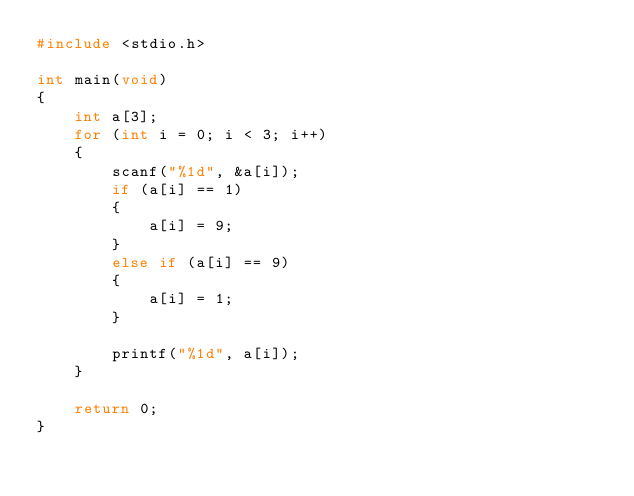<code> <loc_0><loc_0><loc_500><loc_500><_C_>#include <stdio.h>

int main(void)
{
    int a[3];
    for (int i = 0; i < 3; i++)
    {
        scanf("%1d", &a[i]);
        if (a[i] == 1)
        {
            a[i] = 9;
        }
        else if (a[i] == 9)
        {
            a[i] = 1;
        }
        
        printf("%1d", a[i]);
    }
    
    return 0;
}</code> 